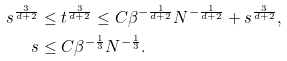<formula> <loc_0><loc_0><loc_500><loc_500>s ^ { \frac { 3 } { d + 2 } } & \leq t ^ { \frac { 3 } { d + 2 } } \leq C \beta ^ { - \frac { 1 } { d + 2 } } N ^ { - \frac { 1 } { d + 2 } } + s ^ { \frac { 3 } { d + 2 } } , \\ s & \leq C \beta ^ { - \frac { 1 } { 3 } } N ^ { - \frac { 1 } { 3 } } .</formula> 